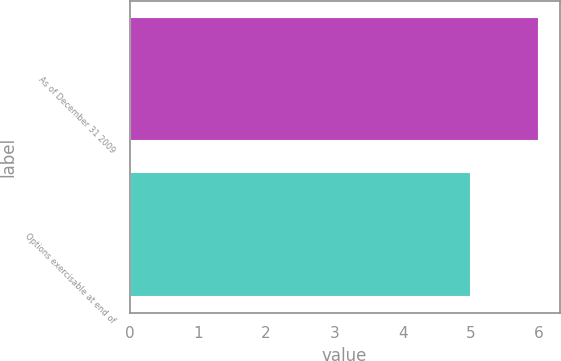Convert chart. <chart><loc_0><loc_0><loc_500><loc_500><bar_chart><fcel>As of December 31 2009<fcel>Options exercisable at end of<nl><fcel>6<fcel>5<nl></chart> 